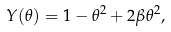<formula> <loc_0><loc_0><loc_500><loc_500>Y ( \theta ) = 1 - \theta ^ { 2 } + 2 \beta \theta ^ { 2 } ,</formula> 